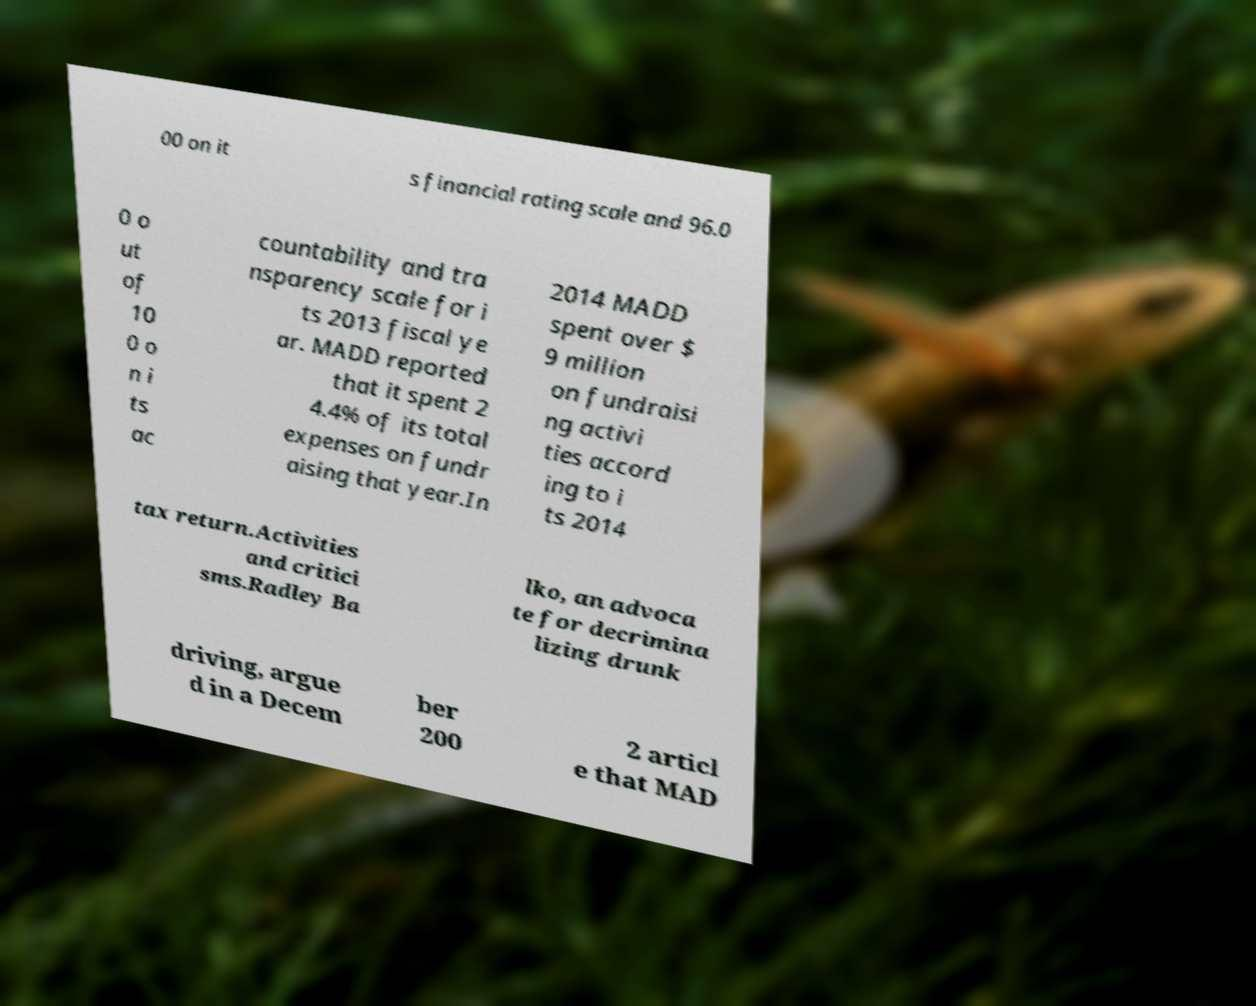There's text embedded in this image that I need extracted. Can you transcribe it verbatim? 00 on it s financial rating scale and 96.0 0 o ut of 10 0 o n i ts ac countability and tra nsparency scale for i ts 2013 fiscal ye ar. MADD reported that it spent 2 4.4% of its total expenses on fundr aising that year.In 2014 MADD spent over $ 9 million on fundraisi ng activi ties accord ing to i ts 2014 tax return.Activities and critici sms.Radley Ba lko, an advoca te for decrimina lizing drunk driving, argue d in a Decem ber 200 2 articl e that MAD 